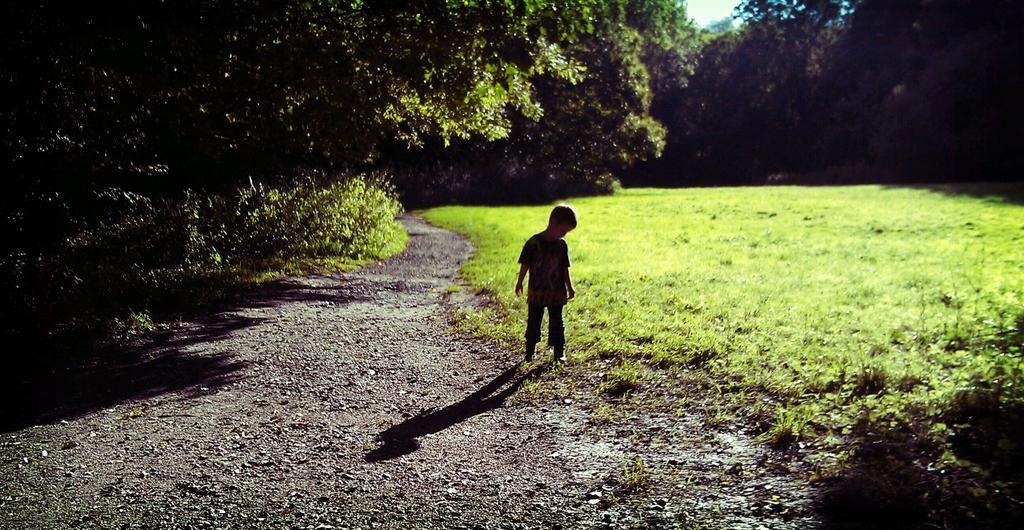How would you summarize this image in a sentence or two? In this picture we can see a kid standing here, at the bottom there is grass, we can see some trees in the background. 